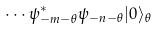<formula> <loc_0><loc_0><loc_500><loc_500>\cdots \psi ^ { * } _ { - m - \theta } \psi _ { - n - \theta } | 0 \rangle _ { \theta }</formula> 